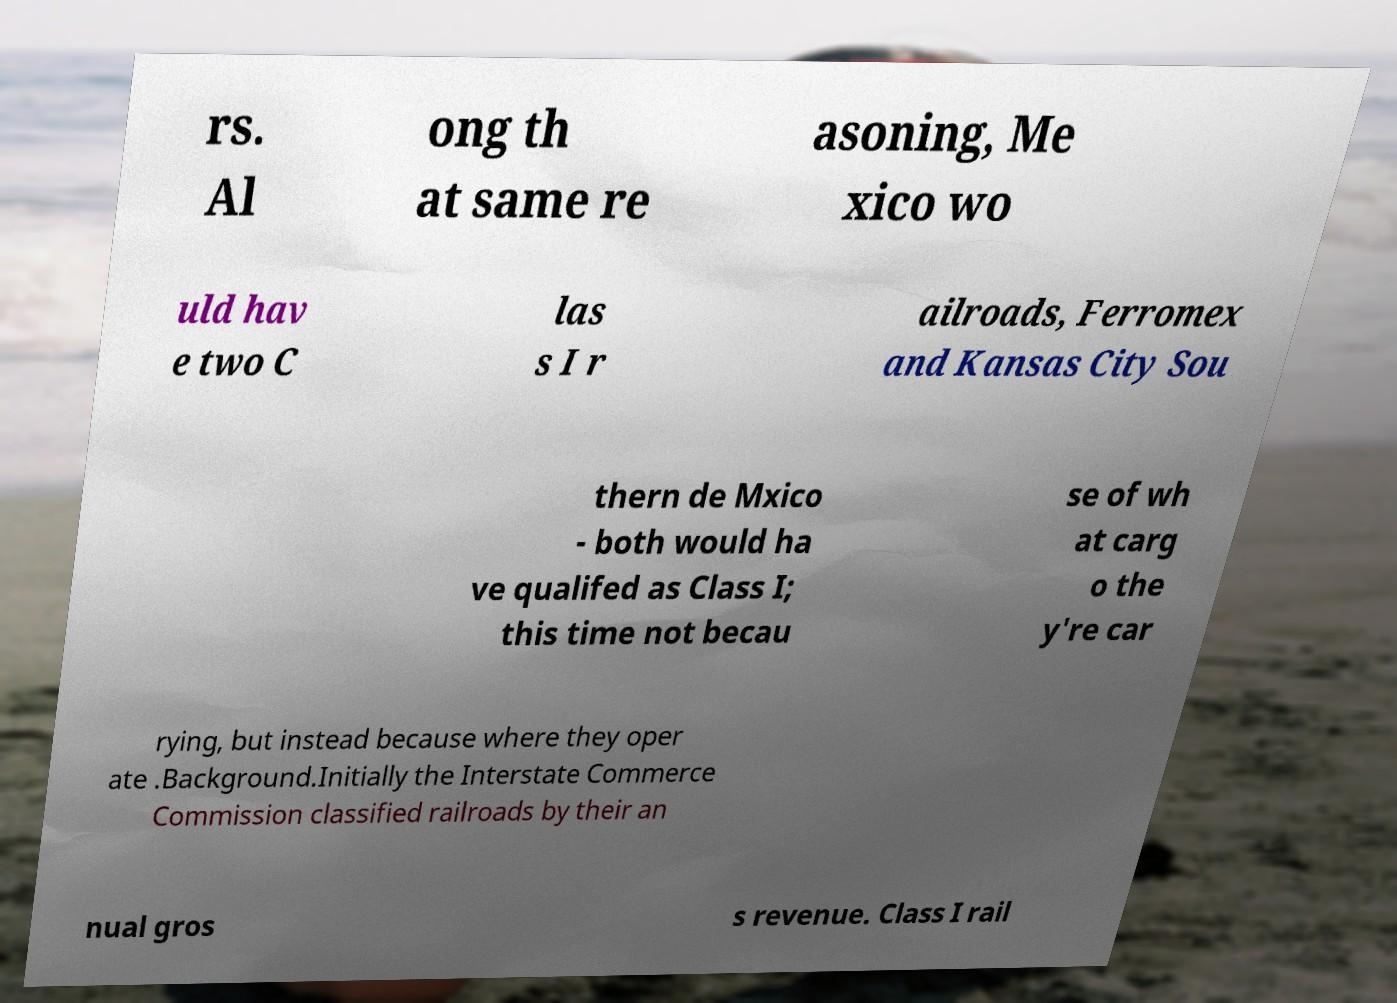For documentation purposes, I need the text within this image transcribed. Could you provide that? rs. Al ong th at same re asoning, Me xico wo uld hav e two C las s I r ailroads, Ferromex and Kansas City Sou thern de Mxico - both would ha ve qualifed as Class I; this time not becau se of wh at carg o the y're car rying, but instead because where they oper ate .Background.Initially the Interstate Commerce Commission classified railroads by their an nual gros s revenue. Class I rail 